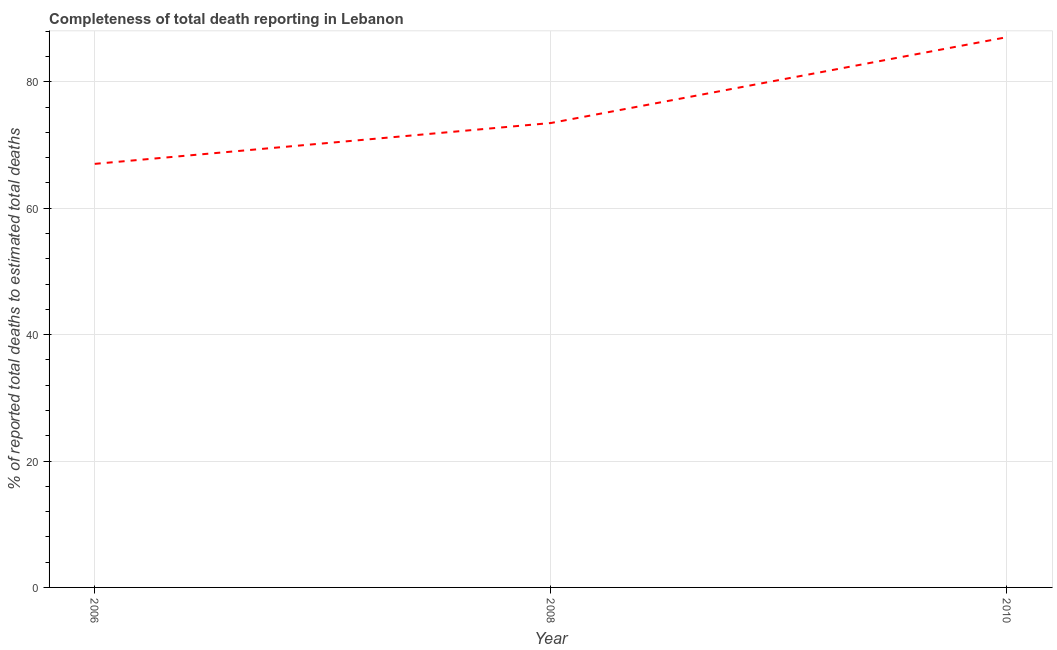What is the completeness of total death reports in 2010?
Your answer should be compact. 87.08. Across all years, what is the maximum completeness of total death reports?
Your response must be concise. 87.08. Across all years, what is the minimum completeness of total death reports?
Your answer should be compact. 67.02. In which year was the completeness of total death reports maximum?
Your answer should be very brief. 2010. What is the sum of the completeness of total death reports?
Keep it short and to the point. 227.59. What is the difference between the completeness of total death reports in 2006 and 2008?
Keep it short and to the point. -6.46. What is the average completeness of total death reports per year?
Ensure brevity in your answer.  75.86. What is the median completeness of total death reports?
Provide a short and direct response. 73.49. In how many years, is the completeness of total death reports greater than 24 %?
Provide a succinct answer. 3. What is the ratio of the completeness of total death reports in 2006 to that in 2010?
Ensure brevity in your answer.  0.77. What is the difference between the highest and the second highest completeness of total death reports?
Your answer should be very brief. 13.59. Is the sum of the completeness of total death reports in 2006 and 2010 greater than the maximum completeness of total death reports across all years?
Ensure brevity in your answer.  Yes. What is the difference between the highest and the lowest completeness of total death reports?
Ensure brevity in your answer.  20.05. In how many years, is the completeness of total death reports greater than the average completeness of total death reports taken over all years?
Ensure brevity in your answer.  1. How many lines are there?
Give a very brief answer. 1. How many years are there in the graph?
Give a very brief answer. 3. What is the difference between two consecutive major ticks on the Y-axis?
Make the answer very short. 20. Are the values on the major ticks of Y-axis written in scientific E-notation?
Ensure brevity in your answer.  No. Does the graph contain any zero values?
Provide a succinct answer. No. Does the graph contain grids?
Provide a short and direct response. Yes. What is the title of the graph?
Provide a succinct answer. Completeness of total death reporting in Lebanon. What is the label or title of the Y-axis?
Keep it short and to the point. % of reported total deaths to estimated total deaths. What is the % of reported total deaths to estimated total deaths in 2006?
Give a very brief answer. 67.02. What is the % of reported total deaths to estimated total deaths of 2008?
Offer a terse response. 73.49. What is the % of reported total deaths to estimated total deaths of 2010?
Your answer should be very brief. 87.08. What is the difference between the % of reported total deaths to estimated total deaths in 2006 and 2008?
Give a very brief answer. -6.46. What is the difference between the % of reported total deaths to estimated total deaths in 2006 and 2010?
Offer a very short reply. -20.05. What is the difference between the % of reported total deaths to estimated total deaths in 2008 and 2010?
Make the answer very short. -13.59. What is the ratio of the % of reported total deaths to estimated total deaths in 2006 to that in 2008?
Give a very brief answer. 0.91. What is the ratio of the % of reported total deaths to estimated total deaths in 2006 to that in 2010?
Offer a terse response. 0.77. What is the ratio of the % of reported total deaths to estimated total deaths in 2008 to that in 2010?
Your answer should be compact. 0.84. 